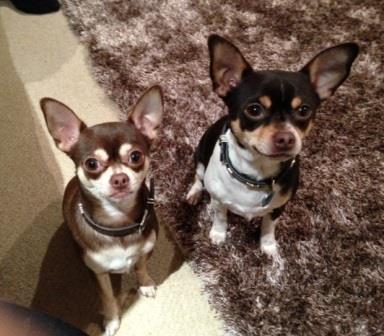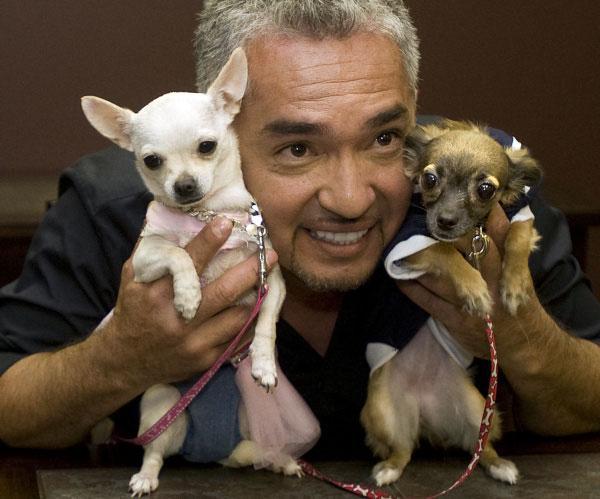The first image is the image on the left, the second image is the image on the right. Assess this claim about the two images: "An image shows two small chihuahuas, one on each side of a male person facing the camera.". Correct or not? Answer yes or no. Yes. The first image is the image on the left, the second image is the image on the right. Evaluate the accuracy of this statement regarding the images: "The right image contains exactly two dogs.". Is it true? Answer yes or no. Yes. 